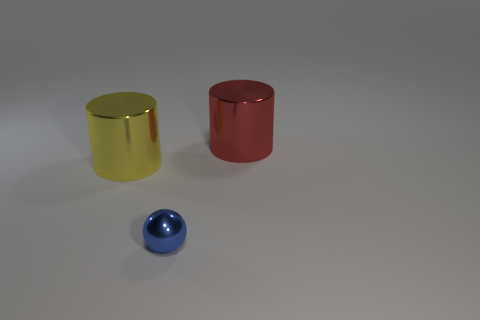How would you describe the colors of these objects? The objects exhibit vibrant and glossy colors with the blue ball having a reflective metallic blue hue, while the cylinders are in glossy metallic yellow and red. 